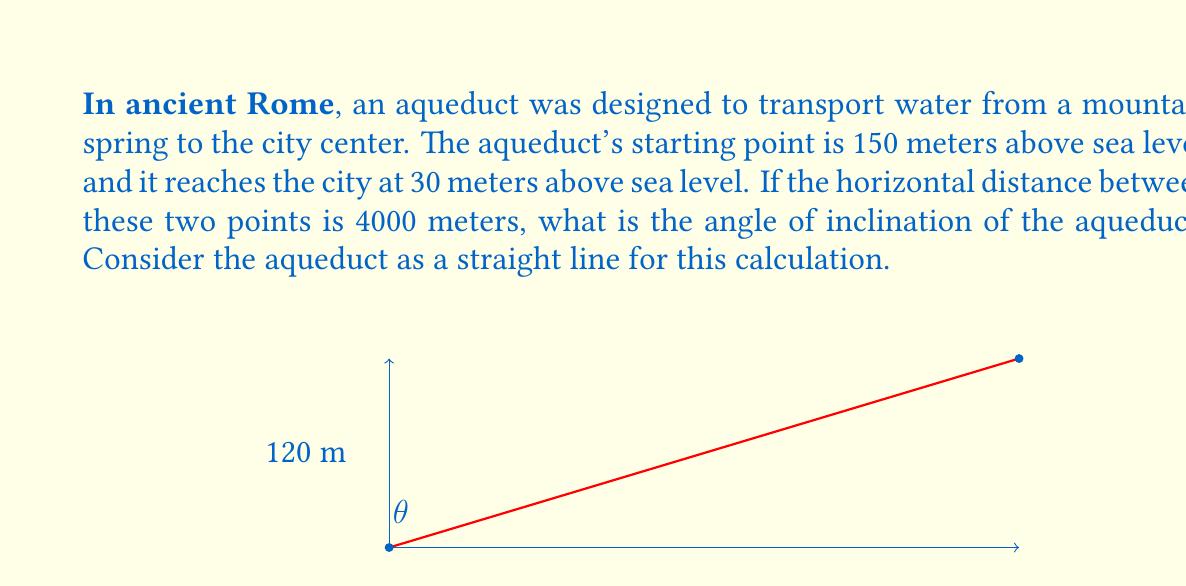Could you help me with this problem? To solve this problem, we can use trigonometry, specifically the tangent function. Let's break it down step by step:

1. Identify the key information:
   - Vertical distance (rise) = 150 m - 30 m = 120 m
   - Horizontal distance (run) = 4000 m

2. The angle of inclination is the angle between the horizontal plane and the aqueduct. We can find this using the tangent function.

3. The tangent of an angle in a right triangle is the ratio of the opposite side to the adjacent side:

   $$ \tan \theta = \frac{\text{opposite}}{\text{adjacent}} = \frac{\text{rise}}{\text{run}} $$

4. Substituting our values:

   $$ \tan \theta = \frac{120}{4000} = 0.03 $$

5. To find the angle $\theta$, we need to use the inverse tangent (arctan or $\tan^{-1}$) function:

   $$ \theta = \tan^{-1}(0.03) $$

6. Using a calculator or trigonometric tables:

   $$ \theta \approx 1.7184^\circ $$

This angle represents the slope of the aqueduct, which is relatively gentle, allowing for a steady flow of water over a long distance. This gradual incline was crucial for ancient Roman engineers to maintain consistent water pressure and prevent damage to the aqueduct structure.
Answer: $$ \theta \approx 1.7184^\circ $$ 